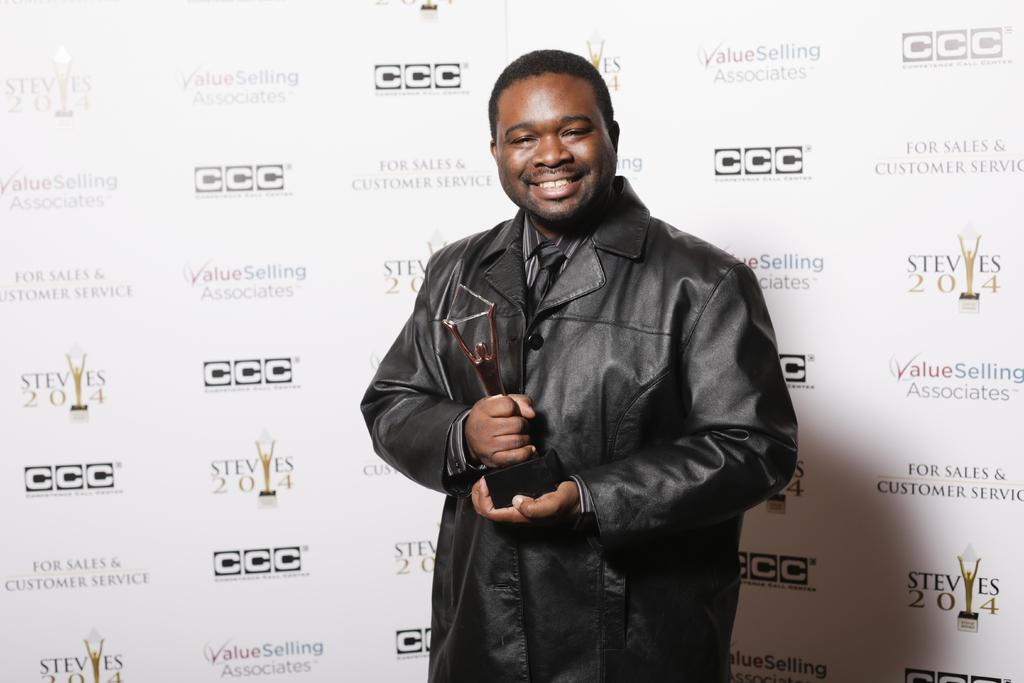Who is present in the image? There is a man in the image. What is the man wearing? The man is wearing a black jacket. What is the man holding in the image? The man is holding an award. What is the man's facial expression? The man is smiling. What can be seen in the background of the image? There is a hoarding in the background of the image. What type of ink is the man using to write his acceptance speech in the image? There is no indication in the image that the man is writing an acceptance speech or using any ink. 